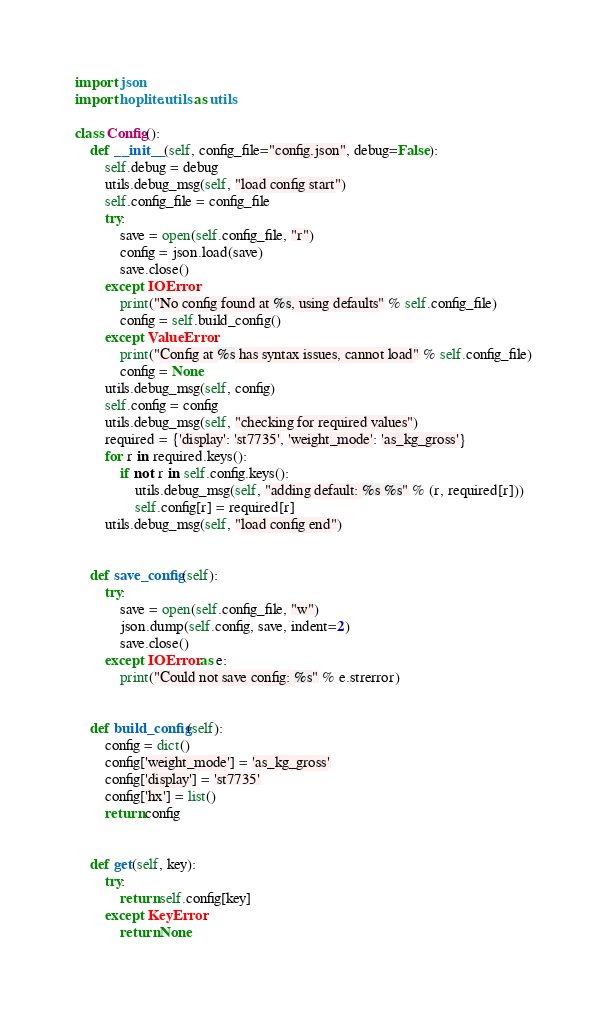<code> <loc_0><loc_0><loc_500><loc_500><_Python_>import json
import hoplite.utils as utils

class Config():
    def __init__(self, config_file="config.json", debug=False):
        self.debug = debug
        utils.debug_msg(self, "load config start")
        self.config_file = config_file
        try: 
            save = open(self.config_file, "r")
            config = json.load(save)
            save.close()
        except IOError:
            print("No config found at %s, using defaults" % self.config_file)
            config = self.build_config()
        except ValueError:
            print("Config at %s has syntax issues, cannot load" % self.config_file)
            config = None
        utils.debug_msg(self, config)
        self.config = config
        utils.debug_msg(self, "checking for required values")
        required = {'display': 'st7735', 'weight_mode': 'as_kg_gross'}
        for r in required.keys():
            if not r in self.config.keys():
                utils.debug_msg(self, "adding default: %s %s" % (r, required[r]))
                self.config[r] = required[r]
        utils.debug_msg(self, "load config end")


    def save_config(self):
        try:
            save = open(self.config_file, "w")
            json.dump(self.config, save, indent=2)
            save.close()
        except IOError as e:
            print("Could not save config: %s" % e.strerror)


    def build_config(self):
        config = dict()
        config['weight_mode'] = 'as_kg_gross'
        config['display'] = 'st7735'
        config['hx'] = list()
        return config


    def get(self, key):
        try:
            return self.config[key]
        except KeyError:
            return None
</code> 